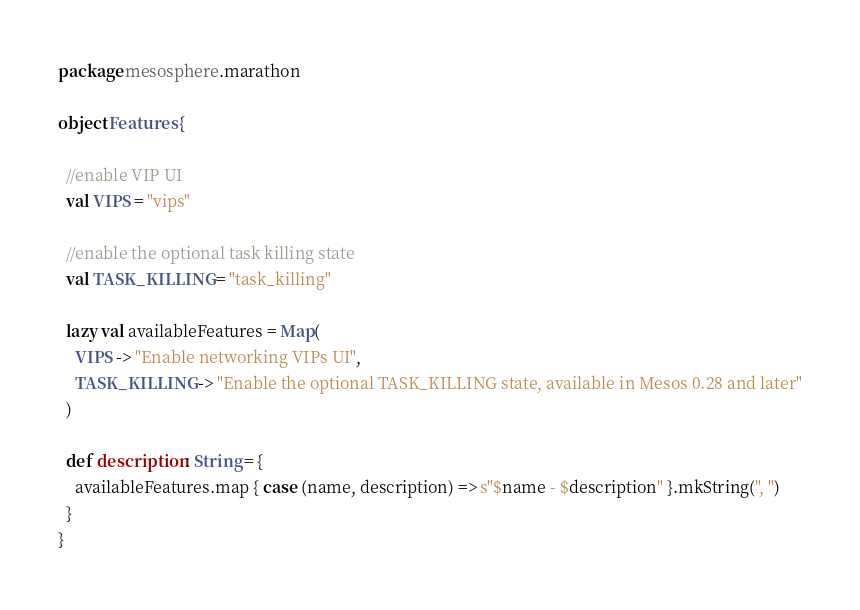<code> <loc_0><loc_0><loc_500><loc_500><_Scala_>package mesosphere.marathon

object Features {

  //enable VIP UI
  val VIPS = "vips"

  //enable the optional task killing state
  val TASK_KILLING = "task_killing"

  lazy val availableFeatures = Map(
    VIPS -> "Enable networking VIPs UI",
    TASK_KILLING -> "Enable the optional TASK_KILLING state, available in Mesos 0.28 and later"
  )

  def description: String = {
    availableFeatures.map { case (name, description) => s"$name - $description" }.mkString(", ")
  }
}
</code> 